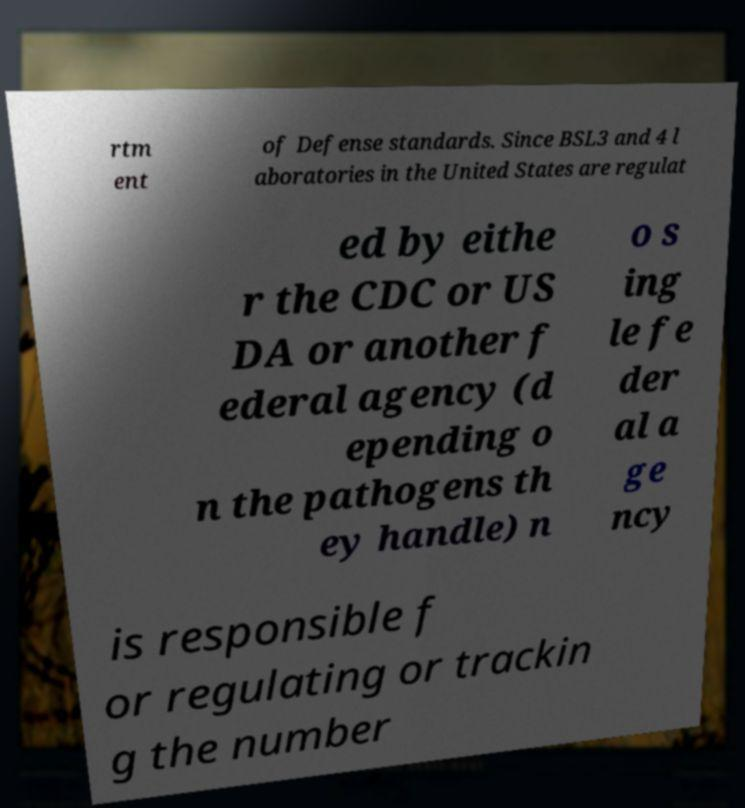Can you accurately transcribe the text from the provided image for me? rtm ent of Defense standards. Since BSL3 and 4 l aboratories in the United States are regulat ed by eithe r the CDC or US DA or another f ederal agency (d epending o n the pathogens th ey handle) n o s ing le fe der al a ge ncy is responsible f or regulating or trackin g the number 